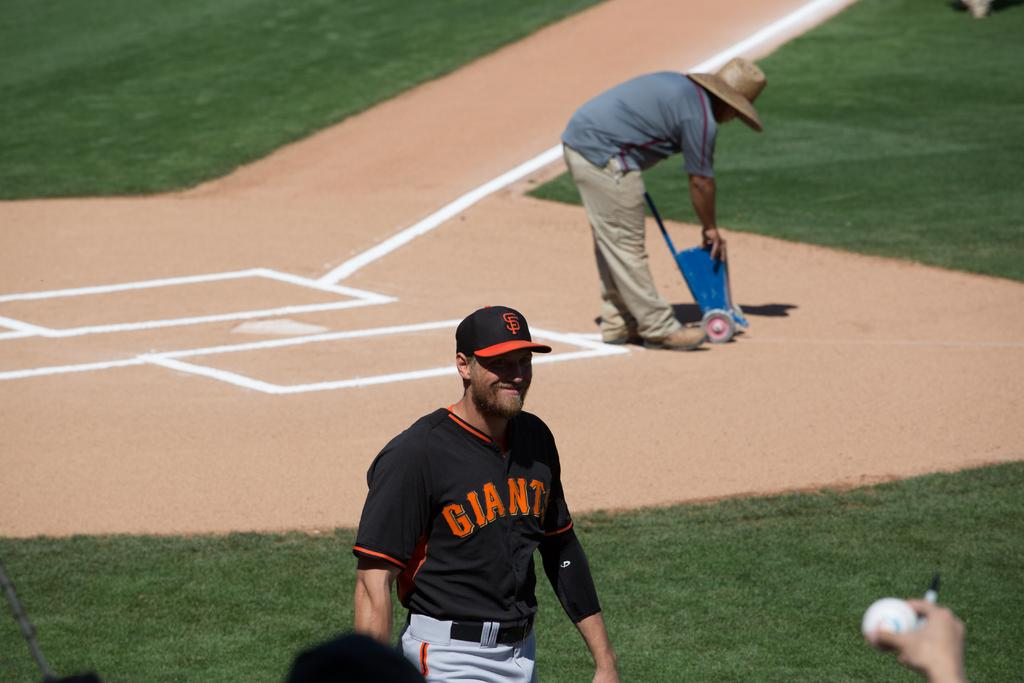<image>
Offer a succinct explanation of the picture presented. A player for the Giants baseball team smiles as he walks across the field. 